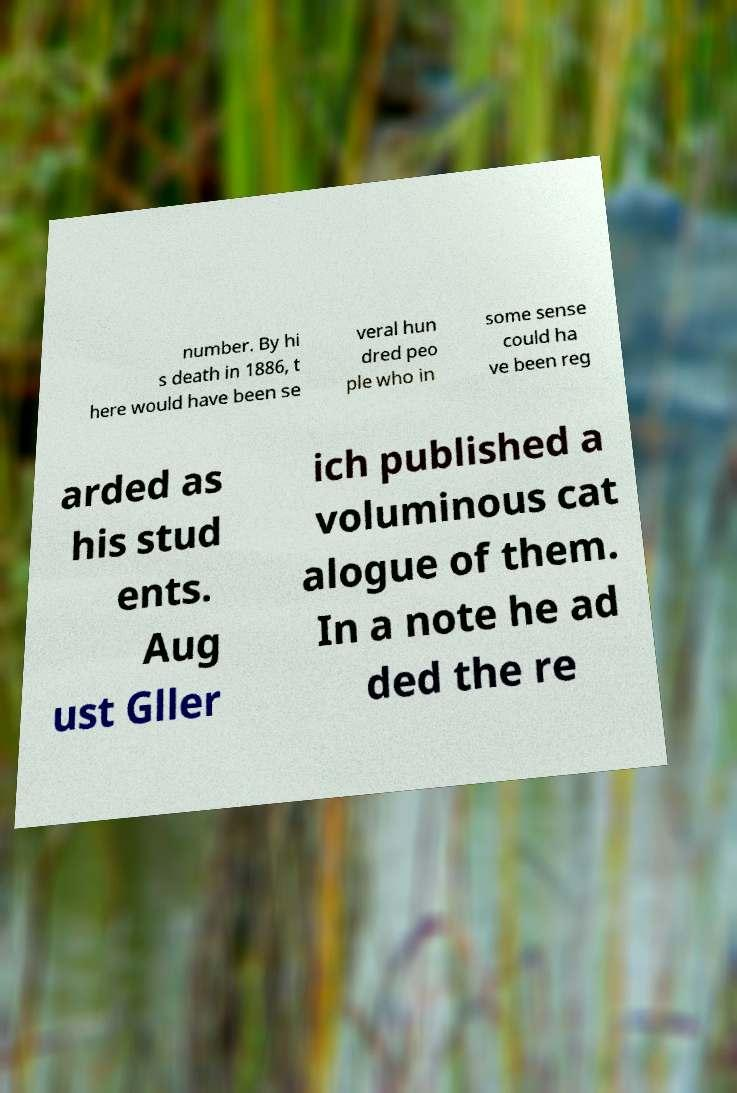For documentation purposes, I need the text within this image transcribed. Could you provide that? number. By hi s death in 1886, t here would have been se veral hun dred peo ple who in some sense could ha ve been reg arded as his stud ents. Aug ust Gller ich published a voluminous cat alogue of them. In a note he ad ded the re 